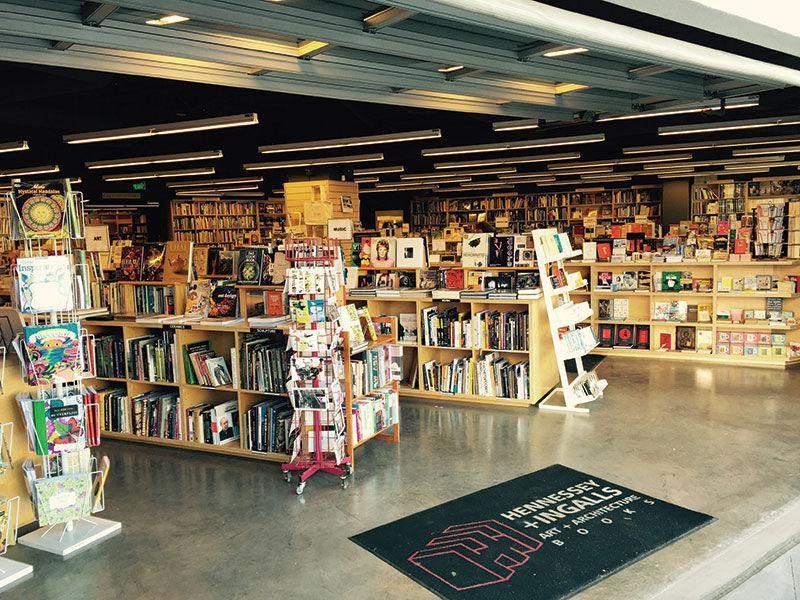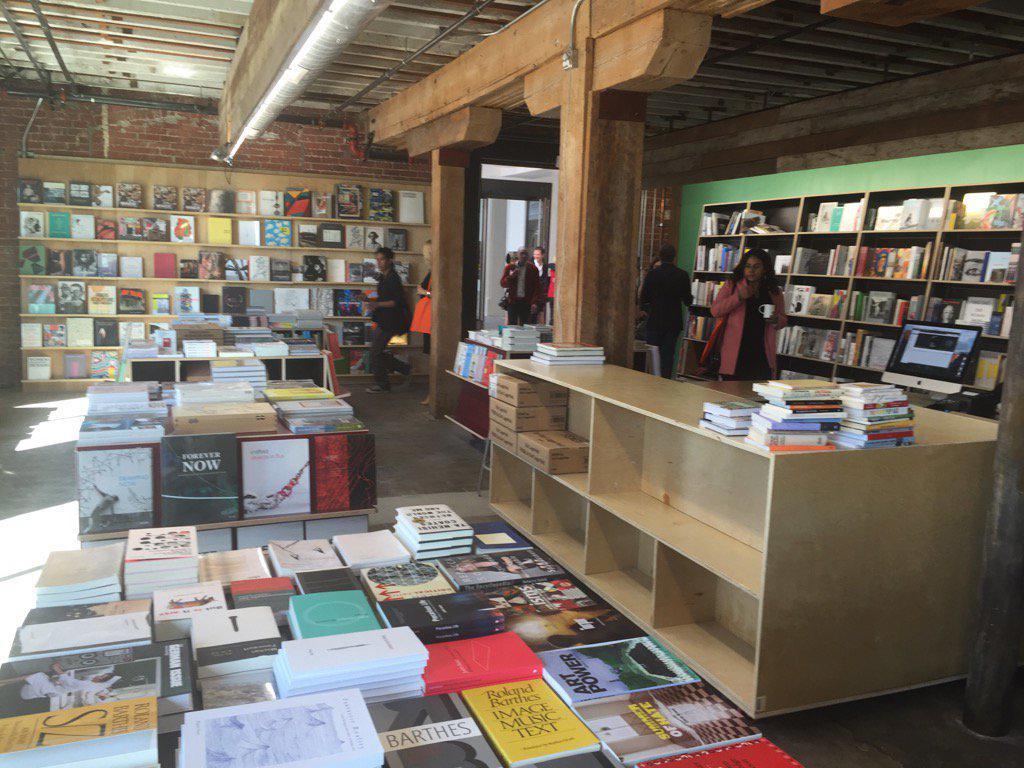The first image is the image on the left, the second image is the image on the right. Given the left and right images, does the statement "The right image shows a bookstore interior with T-shaped wooden support beams in front of a green wall and behind freestanding displays of books." hold true? Answer yes or no. Yes. The first image is the image on the left, the second image is the image on the right. Analyze the images presented: Is the assertion "There are banks of fluorescent lights visible in at least one of the images." valid? Answer yes or no. Yes. 